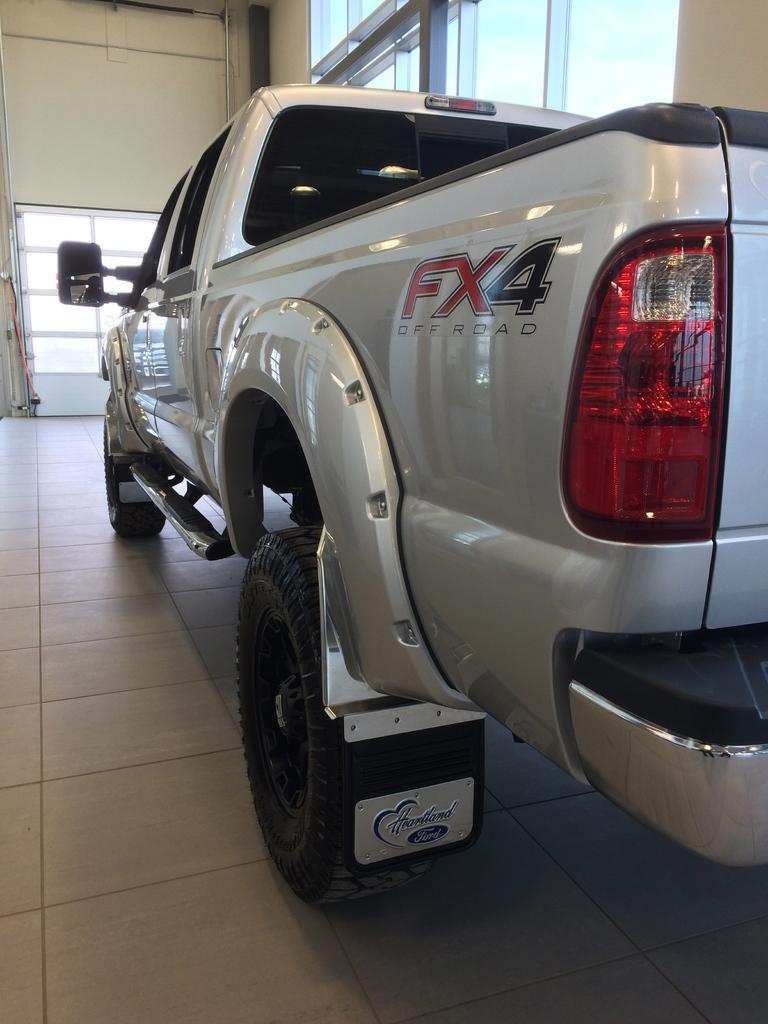Could you give a brief overview of what you see in this image? In this image I see a vehicle over here which is of white in color and I see something is written over here and I see the floor. In the background I see the wall and the windows. 